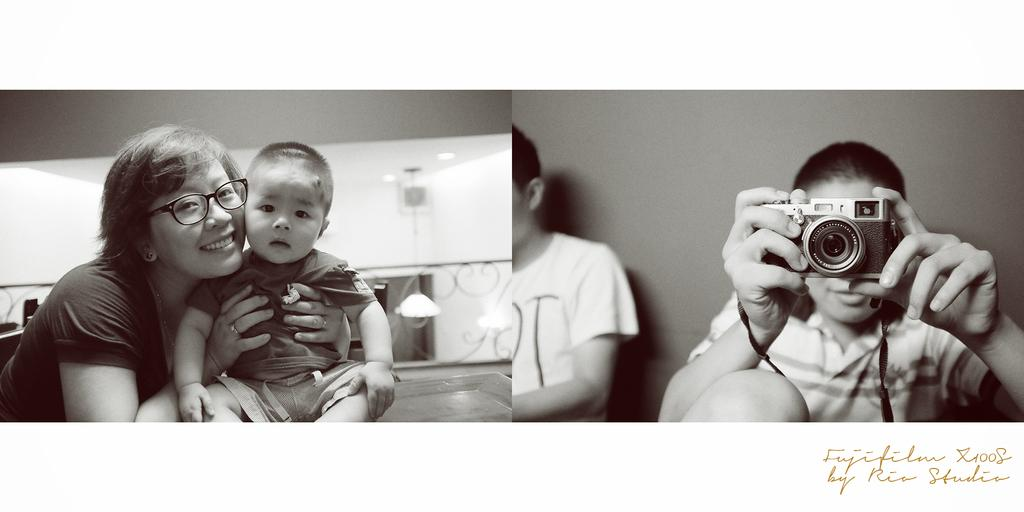What type of structure can be seen in the image? There is a wall in the image. What is covering the wall in the image? There is a sheet in the image. What are the people in the image doing? The people in the image are sitting. Where is the camera located in the image? A man is holding a camera on the right side of the image. How many beds are visible in the image? There are no beds present in the image. What type of quiver is the writer using in the image? There is no writer or quiver present in the image. 